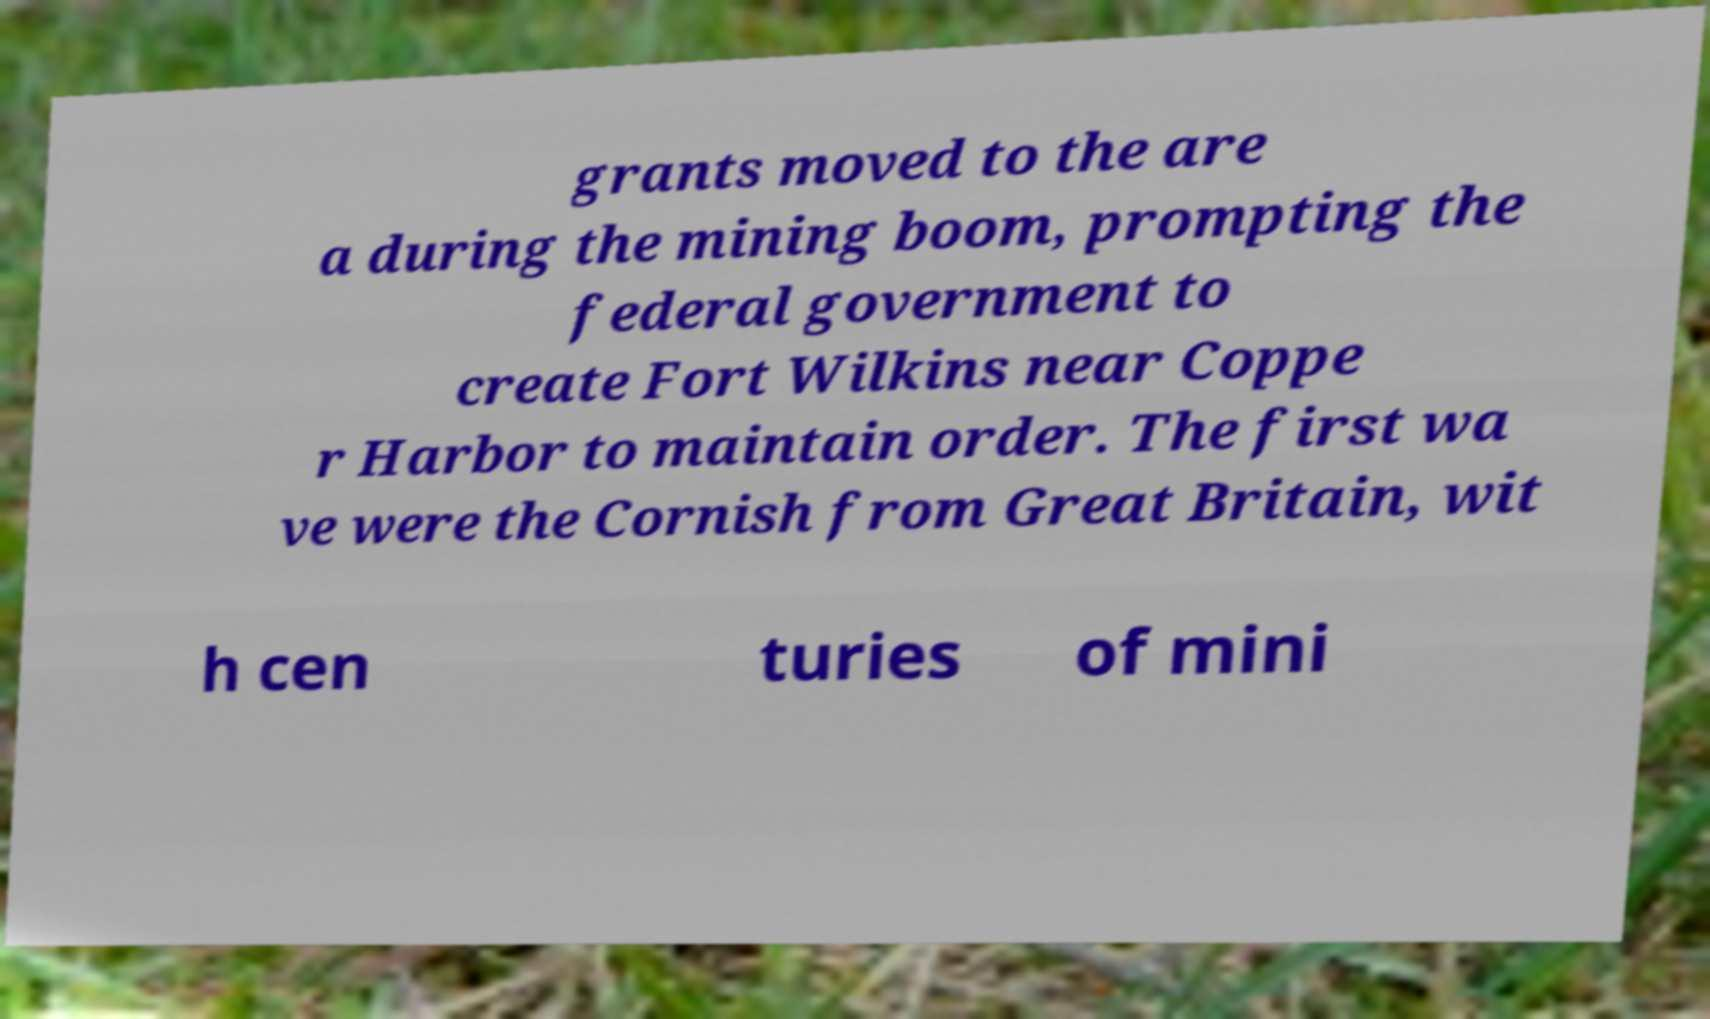There's text embedded in this image that I need extracted. Can you transcribe it verbatim? grants moved to the are a during the mining boom, prompting the federal government to create Fort Wilkins near Coppe r Harbor to maintain order. The first wa ve were the Cornish from Great Britain, wit h cen turies of mini 